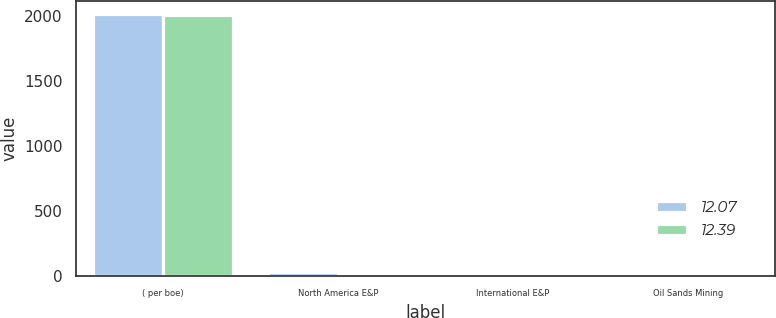Convert chart. <chart><loc_0><loc_0><loc_500><loc_500><stacked_bar_chart><ecel><fcel>( per boe)<fcel>North America E&P<fcel>International E&P<fcel>Oil Sands Mining<nl><fcel>12.07<fcel>2014<fcel>26.95<fcel>5.79<fcel>12.07<nl><fcel>12.39<fcel>2013<fcel>26.23<fcel>5.86<fcel>12.39<nl></chart> 